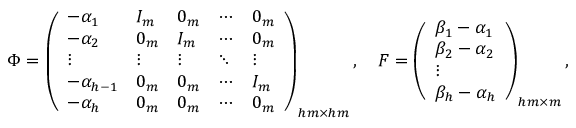Convert formula to latex. <formula><loc_0><loc_0><loc_500><loc_500>\Phi = \left ( \begin{array} { l l l l l } { - \alpha _ { 1 } } & { I _ { m } } & { 0 _ { m } } & { \cdots } & { 0 _ { m } } \\ { - \alpha _ { 2 } } & { 0 _ { m } } & { I _ { m } } & { \cdots } & { 0 _ { m } } \\ { \vdots } & { \vdots } & { \vdots } & { \ddots } & { \vdots } \\ { - \alpha _ { h - 1 } } & { 0 _ { m } } & { 0 _ { m } } & { \cdots } & { I _ { m } } \\ { - \alpha _ { h } } & { 0 _ { m } } & { 0 _ { m } } & { \cdots } & { 0 _ { m } } \end{array} \right ) _ { h m \times h m } , F = \left ( \begin{array} { l } { \beta _ { 1 } - \alpha _ { 1 } } \\ { \beta _ { 2 } - \alpha _ { 2 } } \\ { \vdots } \\ { \beta _ { h } - \alpha _ { h } } \end{array} \right ) _ { h m \times m } ,</formula> 